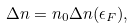<formula> <loc_0><loc_0><loc_500><loc_500>\Delta n = n _ { 0 } \Delta n ( \epsilon _ { F } ) ,</formula> 